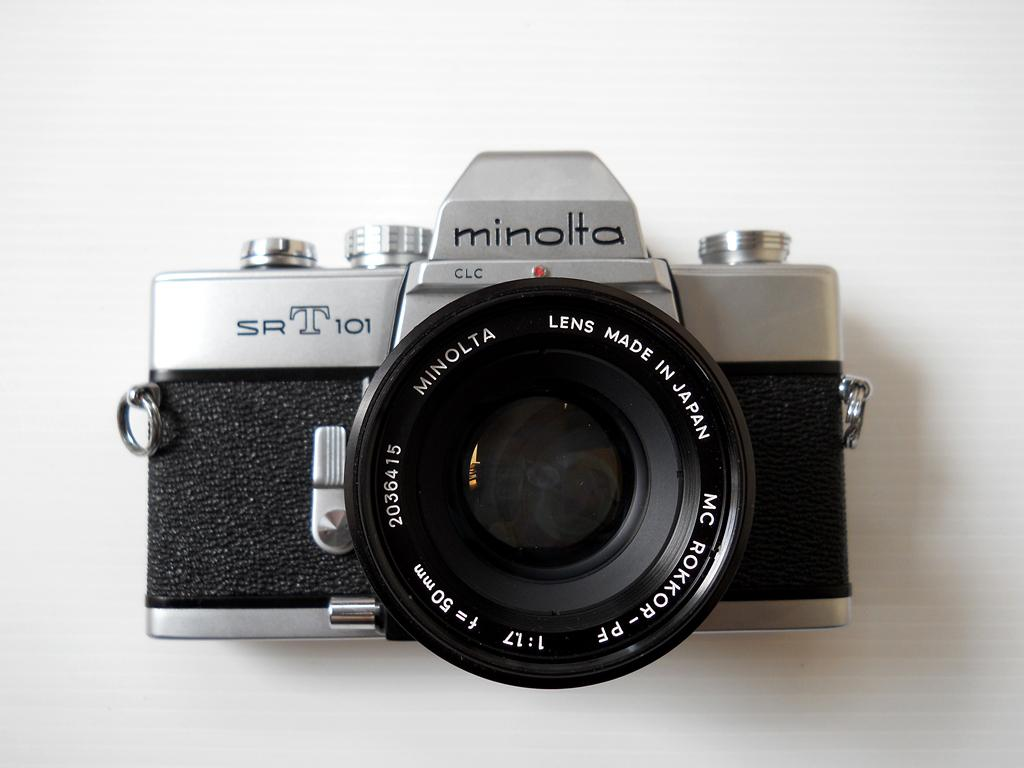<image>
Present a compact description of the photo's key features. A minolta brand camera is on a white background. 